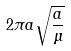Convert formula to latex. <formula><loc_0><loc_0><loc_500><loc_500>2 \pi a \sqrt { \frac { a } { \mu } }</formula> 